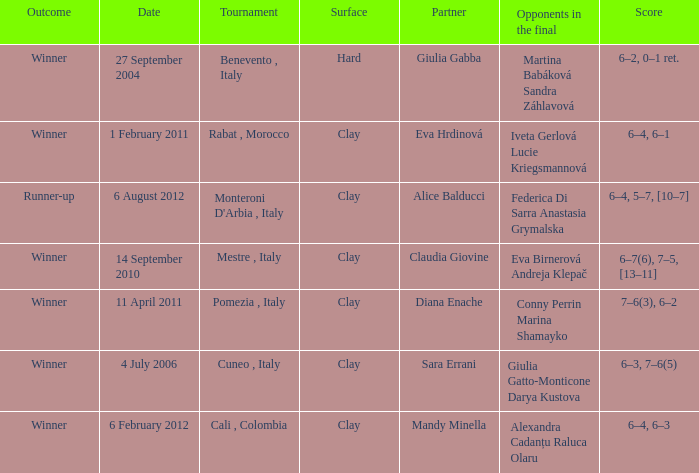Who played on a hard surface? Giulia Gabba. Would you mind parsing the complete table? {'header': ['Outcome', 'Date', 'Tournament', 'Surface', 'Partner', 'Opponents in the final', 'Score'], 'rows': [['Winner', '27 September 2004', 'Benevento , Italy', 'Hard', 'Giulia Gabba', 'Martina Babáková Sandra Záhlavová', '6–2, 0–1 ret.'], ['Winner', '1 February 2011', 'Rabat , Morocco', 'Clay', 'Eva Hrdinová', 'Iveta Gerlová Lucie Kriegsmannová', '6–4, 6–1'], ['Runner-up', '6 August 2012', "Monteroni D'Arbia , Italy", 'Clay', 'Alice Balducci', 'Federica Di Sarra Anastasia Grymalska', '6–4, 5–7, [10–7]'], ['Winner', '14 September 2010', 'Mestre , Italy', 'Clay', 'Claudia Giovine', 'Eva Birnerová Andreja Klepač', '6–7(6), 7–5, [13–11]'], ['Winner', '11 April 2011', 'Pomezia , Italy', 'Clay', 'Diana Enache', 'Conny Perrin Marina Shamayko', '7–6(3), 6–2'], ['Winner', '4 July 2006', 'Cuneo , Italy', 'Clay', 'Sara Errani', 'Giulia Gatto-Monticone Darya Kustova', '6–3, 7–6(5)'], ['Winner', '6 February 2012', 'Cali , Colombia', 'Clay', 'Mandy Minella', 'Alexandra Cadanțu Raluca Olaru', '6–4, 6–3']]} 